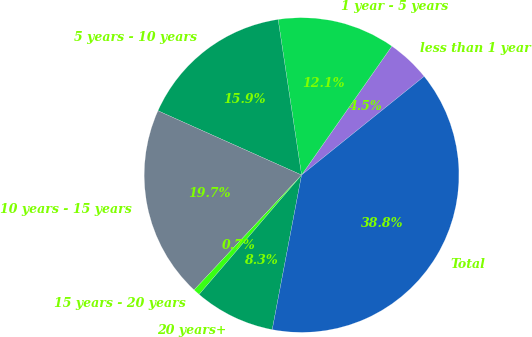Convert chart to OTSL. <chart><loc_0><loc_0><loc_500><loc_500><pie_chart><fcel>less than 1 year<fcel>1 year - 5 years<fcel>5 years - 10 years<fcel>10 years - 15 years<fcel>15 years - 20 years<fcel>20 years+<fcel>Total<nl><fcel>4.49%<fcel>12.11%<fcel>15.92%<fcel>19.73%<fcel>0.68%<fcel>8.3%<fcel>38.77%<nl></chart> 